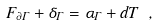<formula> <loc_0><loc_0><loc_500><loc_500>F _ { \partial \Gamma } + \delta _ { \Gamma } = \alpha _ { \Gamma } + d T \ ,</formula> 